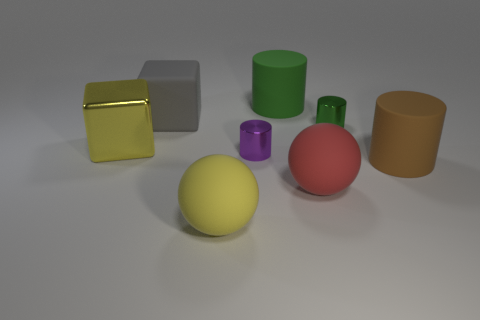Is there a matte cylinder that has the same color as the big metal thing?
Keep it short and to the point. No. There is a big object that is left of the gray rubber thing; what shape is it?
Ensure brevity in your answer.  Cube. What is the color of the large metal cube?
Give a very brief answer. Yellow. There is a big sphere that is made of the same material as the red object; what is its color?
Make the answer very short. Yellow. How many tiny green cylinders are the same material as the brown thing?
Provide a short and direct response. 0. There is a brown matte cylinder; what number of big gray matte objects are left of it?
Your answer should be very brief. 1. Does the purple object that is to the left of the brown rubber thing have the same material as the yellow object that is to the left of the big gray block?
Your answer should be compact. Yes. Are there more matte cylinders on the left side of the tiny green thing than red objects that are right of the large green rubber cylinder?
Provide a short and direct response. No. There is another big object that is the same color as the large metallic thing; what is it made of?
Offer a very short reply. Rubber. Is there any other thing that has the same shape as the tiny purple shiny thing?
Provide a succinct answer. Yes. 